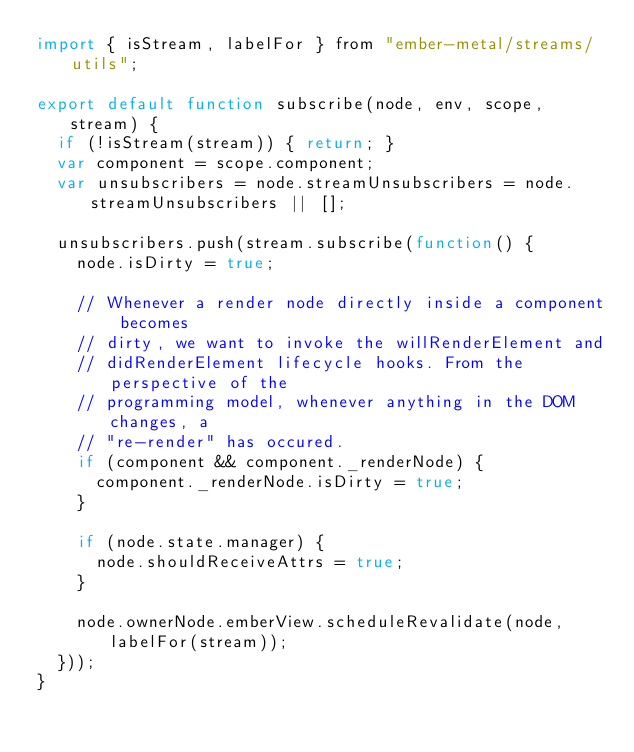<code> <loc_0><loc_0><loc_500><loc_500><_JavaScript_>import { isStream, labelFor } from "ember-metal/streams/utils";

export default function subscribe(node, env, scope, stream) {
  if (!isStream(stream)) { return; }
  var component = scope.component;
  var unsubscribers = node.streamUnsubscribers = node.streamUnsubscribers || [];

  unsubscribers.push(stream.subscribe(function() {
    node.isDirty = true;

    // Whenever a render node directly inside a component becomes
    // dirty, we want to invoke the willRenderElement and
    // didRenderElement lifecycle hooks. From the perspective of the
    // programming model, whenever anything in the DOM changes, a
    // "re-render" has occured.
    if (component && component._renderNode) {
      component._renderNode.isDirty = true;
    }

    if (node.state.manager) {
      node.shouldReceiveAttrs = true;
    }

    node.ownerNode.emberView.scheduleRevalidate(node, labelFor(stream));
  }));
}
</code> 